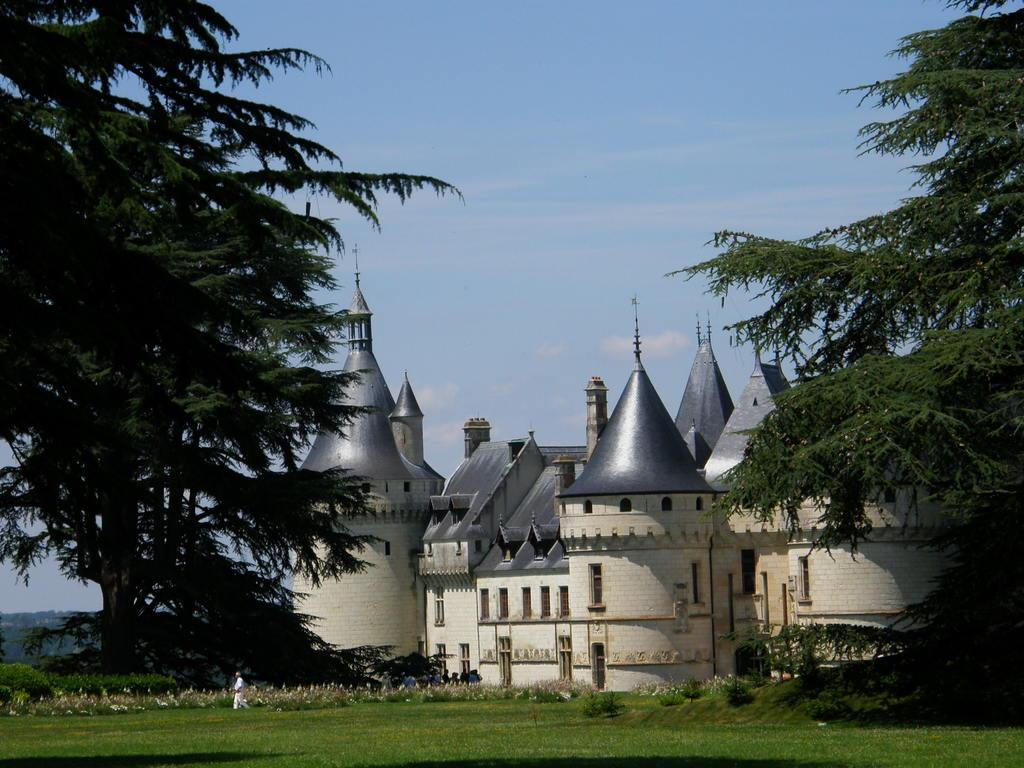What type of structure is present in the image? There is a building with windows in the image. What can be seen on the ground in the image? There is grass visible in the image. What type of vegetation with flowers can be seen in the image? There are plants with flowers in the image. What other type of vegetation is present in the image? There are trees in the image. Can you describe the person in the image? There is a person standing on the ground in the image. What is visible in the sky in the image? The sky is visible in the image and appears cloudy. Is there a bat flying in the winter sky in the image? There is no bat flying in the image, and the season is not specified, so it cannot be determined if it is winter. 